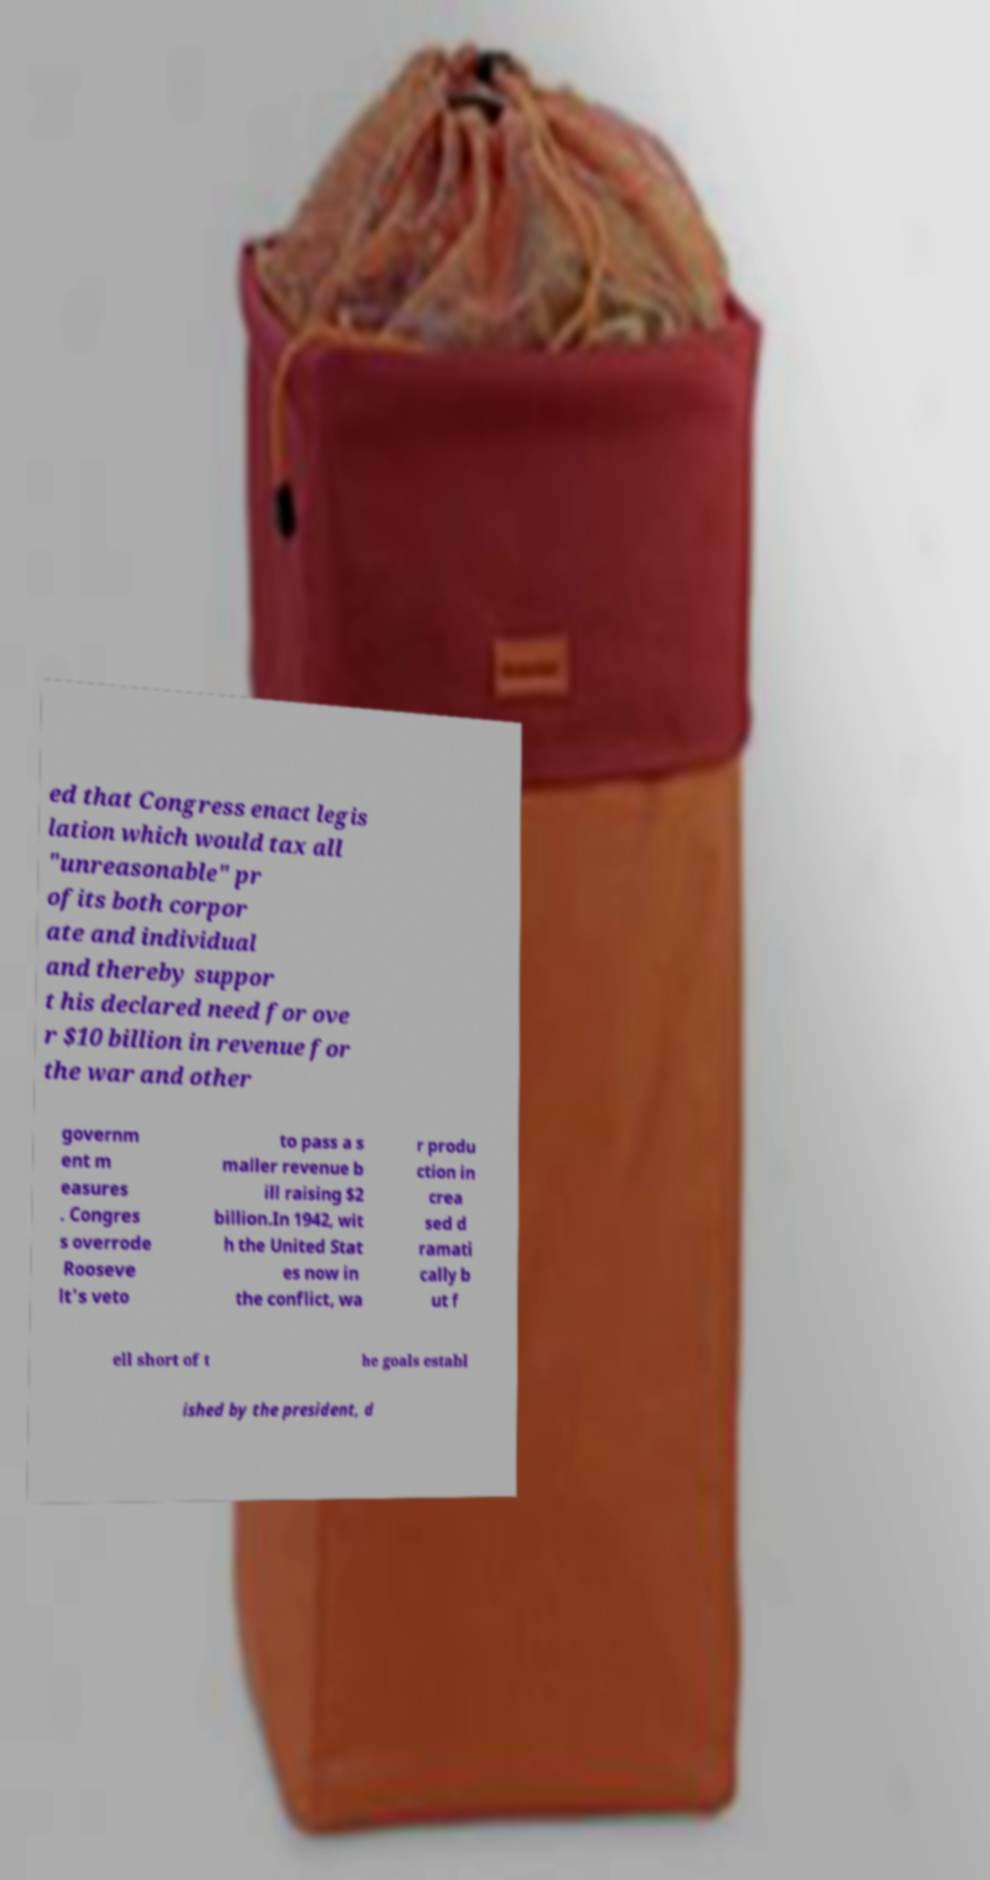What messages or text are displayed in this image? I need them in a readable, typed format. ed that Congress enact legis lation which would tax all "unreasonable" pr ofits both corpor ate and individual and thereby suppor t his declared need for ove r $10 billion in revenue for the war and other governm ent m easures . Congres s overrode Rooseve lt's veto to pass a s maller revenue b ill raising $2 billion.In 1942, wit h the United Stat es now in the conflict, wa r produ ction in crea sed d ramati cally b ut f ell short of t he goals establ ished by the president, d 